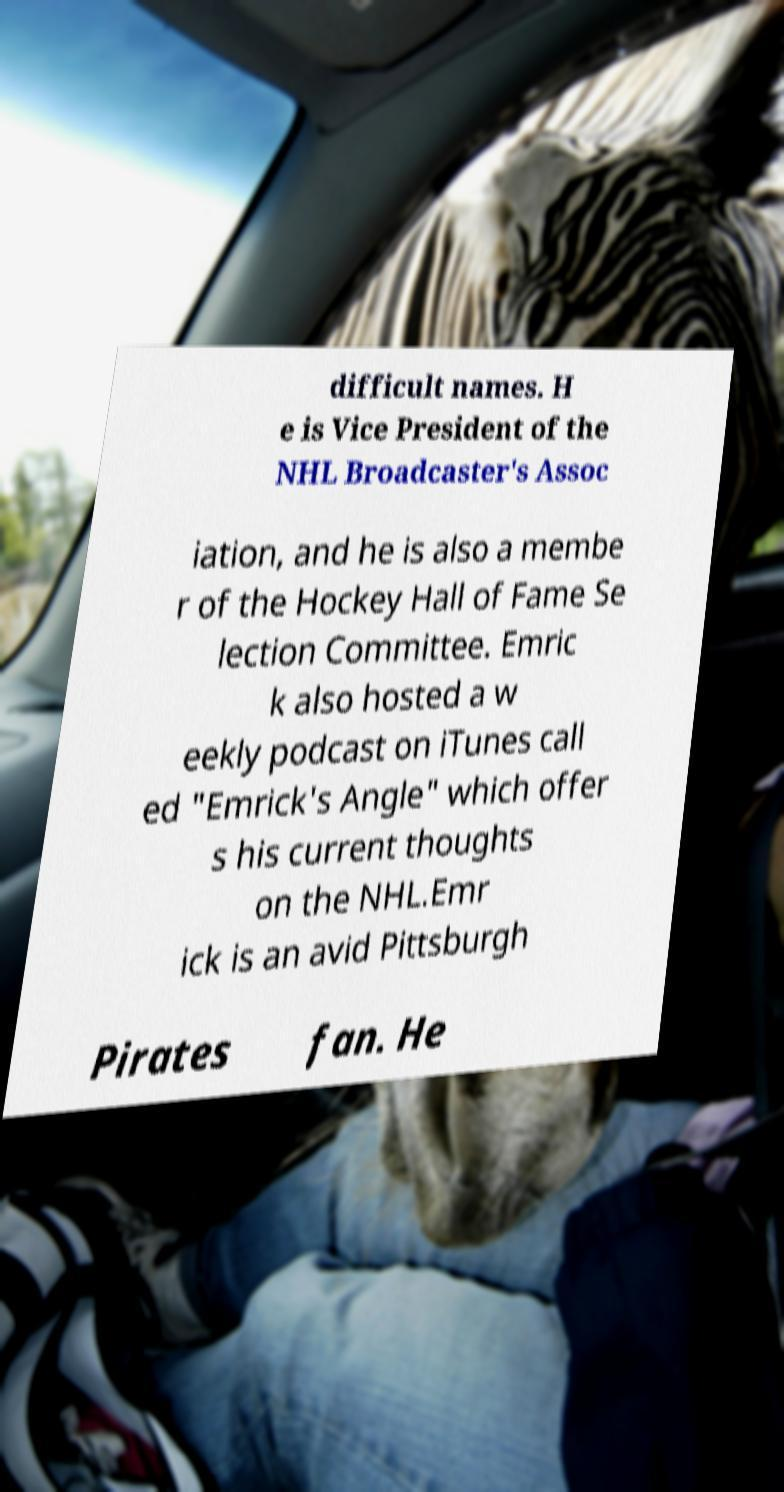What messages or text are displayed in this image? I need them in a readable, typed format. difficult names. H e is Vice President of the NHL Broadcaster's Assoc iation, and he is also a membe r of the Hockey Hall of Fame Se lection Committee. Emric k also hosted a w eekly podcast on iTunes call ed "Emrick's Angle" which offer s his current thoughts on the NHL.Emr ick is an avid Pittsburgh Pirates fan. He 